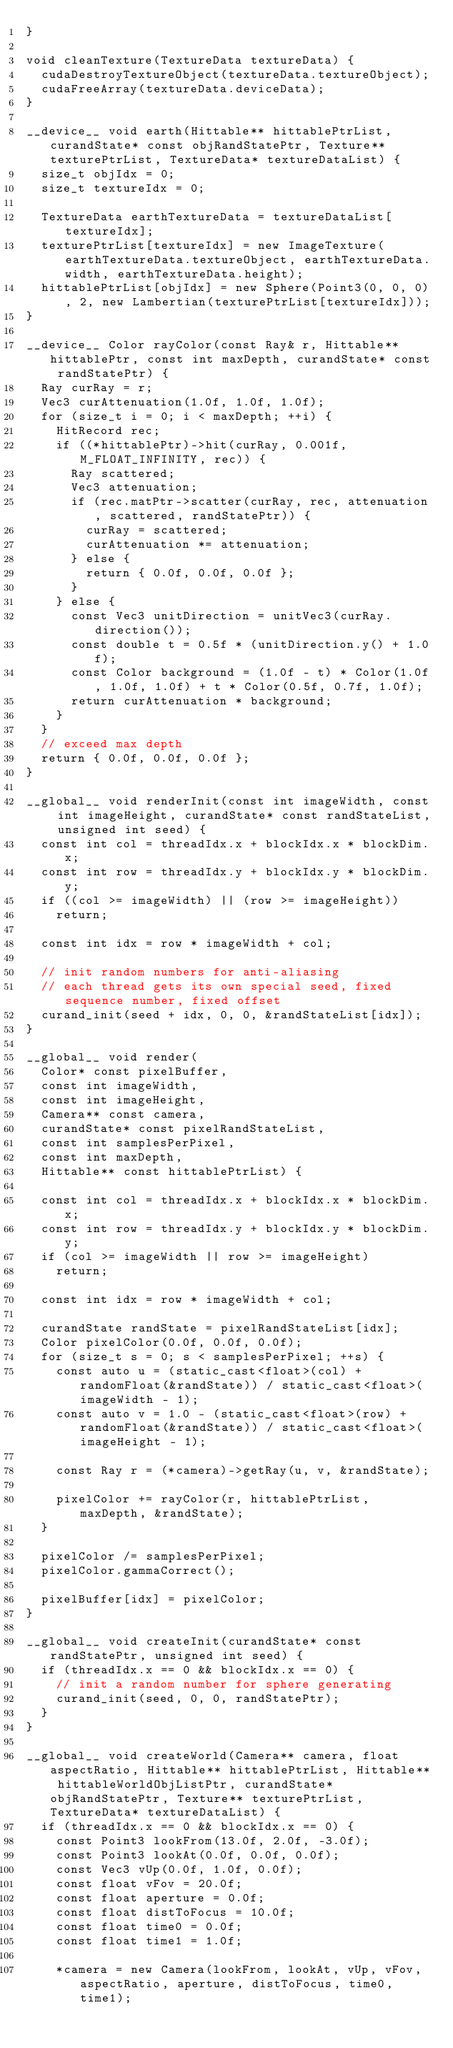<code> <loc_0><loc_0><loc_500><loc_500><_Cuda_>}

void cleanTexture(TextureData textureData) {
	cudaDestroyTextureObject(textureData.textureObject);
	cudaFreeArray(textureData.deviceData);
}

__device__ void earth(Hittable** hittablePtrList, curandState* const objRandStatePtr, Texture** texturePtrList, TextureData* textureDataList) {
	size_t objIdx = 0;
	size_t textureIdx = 0;

	TextureData earthTextureData = textureDataList[textureIdx];
	texturePtrList[textureIdx] = new ImageTexture(earthTextureData.textureObject, earthTextureData.width, earthTextureData.height);
	hittablePtrList[objIdx] = new Sphere(Point3(0, 0, 0), 2, new Lambertian(texturePtrList[textureIdx]));
}

__device__ Color rayColor(const Ray& r, Hittable** hittablePtr, const int maxDepth, curandState* const randStatePtr) {
	Ray curRay = r;
	Vec3 curAttenuation(1.0f, 1.0f, 1.0f);
	for (size_t i = 0; i < maxDepth; ++i) {
		HitRecord rec;
		if ((*hittablePtr)->hit(curRay, 0.001f, M_FLOAT_INFINITY, rec)) {
			Ray scattered;
			Vec3 attenuation;
			if (rec.matPtr->scatter(curRay, rec, attenuation, scattered, randStatePtr)) {
				curRay = scattered;
				curAttenuation *= attenuation;
			} else {
				return { 0.0f, 0.0f, 0.0f };
			}
		} else {
			const Vec3 unitDirection = unitVec3(curRay.direction());
			const double t = 0.5f * (unitDirection.y() + 1.0f);
			const Color background = (1.0f - t) * Color(1.0f, 1.0f, 1.0f) + t * Color(0.5f, 0.7f, 1.0f);
			return curAttenuation * background;
		}
	}
	// exceed max depth
	return { 0.0f, 0.0f, 0.0f };
}

__global__ void renderInit(const int imageWidth, const int imageHeight, curandState* const randStateList, unsigned int seed) {
	const int col = threadIdx.x + blockIdx.x * blockDim.x;
	const int row = threadIdx.y + blockIdx.y * blockDim.y;
	if ((col >= imageWidth) || (row >= imageHeight))
		return;

	const int idx = row * imageWidth + col;

	// init random numbers for anti-aliasing
	// each thread gets its own special seed, fixed sequence number, fixed offset
	curand_init(seed + idx, 0, 0, &randStateList[idx]);
}

__global__ void render(
	Color* const pixelBuffer,
	const int imageWidth,
	const int imageHeight,
	Camera** const camera,
	curandState* const pixelRandStateList,
	const int samplesPerPixel,
	const int maxDepth,
	Hittable** const hittablePtrList) {

	const int col = threadIdx.x + blockIdx.x * blockDim.x;
	const int row = threadIdx.y + blockIdx.y * blockDim.y;
	if (col >= imageWidth || row >= imageHeight)
		return;

	const int idx = row * imageWidth + col;

	curandState randState = pixelRandStateList[idx];
	Color pixelColor(0.0f, 0.0f, 0.0f);
	for (size_t s = 0; s < samplesPerPixel; ++s) {
		const auto u = (static_cast<float>(col) + randomFloat(&randState)) / static_cast<float>(imageWidth - 1);
		const auto v = 1.0 - (static_cast<float>(row) + randomFloat(&randState)) / static_cast<float>(imageHeight - 1);

		const Ray r = (*camera)->getRay(u, v, &randState);

		pixelColor += rayColor(r, hittablePtrList, maxDepth, &randState);
	}

	pixelColor /= samplesPerPixel;
	pixelColor.gammaCorrect();

	pixelBuffer[idx] = pixelColor;
}

__global__ void createInit(curandState* const randStatePtr, unsigned int seed) {
	if (threadIdx.x == 0 && blockIdx.x == 0) {
		// init a random number for sphere generating
		curand_init(seed, 0, 0, randStatePtr);
	}
}

__global__ void createWorld(Camera** camera, float aspectRatio, Hittable** hittablePtrList, Hittable** hittableWorldObjListPtr, curandState* objRandStatePtr, Texture** texturePtrList, TextureData* textureDataList) {
	if (threadIdx.x == 0 && blockIdx.x == 0) {
		const Point3 lookFrom(13.0f, 2.0f, -3.0f);
		const Point3 lookAt(0.0f, 0.0f, 0.0f);
		const Vec3 vUp(0.0f, 1.0f, 0.0f);
		const float vFov = 20.0f;
		const float aperture = 0.0f;
		const float distToFocus = 10.0f;
		const float time0 = 0.0f;
		const float time1 = 1.0f;
		
		*camera = new Camera(lookFrom, lookAt, vUp, vFov, aspectRatio, aperture, distToFocus, time0, time1);
</code> 